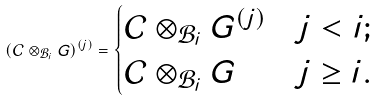<formula> <loc_0><loc_0><loc_500><loc_500>( \mathcal { C } \otimes _ { \mathcal { B } _ { i } } G ) ^ { ( j ) } = \begin{cases} \mathcal { C } \otimes _ { \mathcal { B } _ { i } } G ^ { ( j ) } & j < i ; \\ \mathcal { C } \otimes _ { \mathcal { B } _ { i } } G & j \geq i . \end{cases}</formula> 